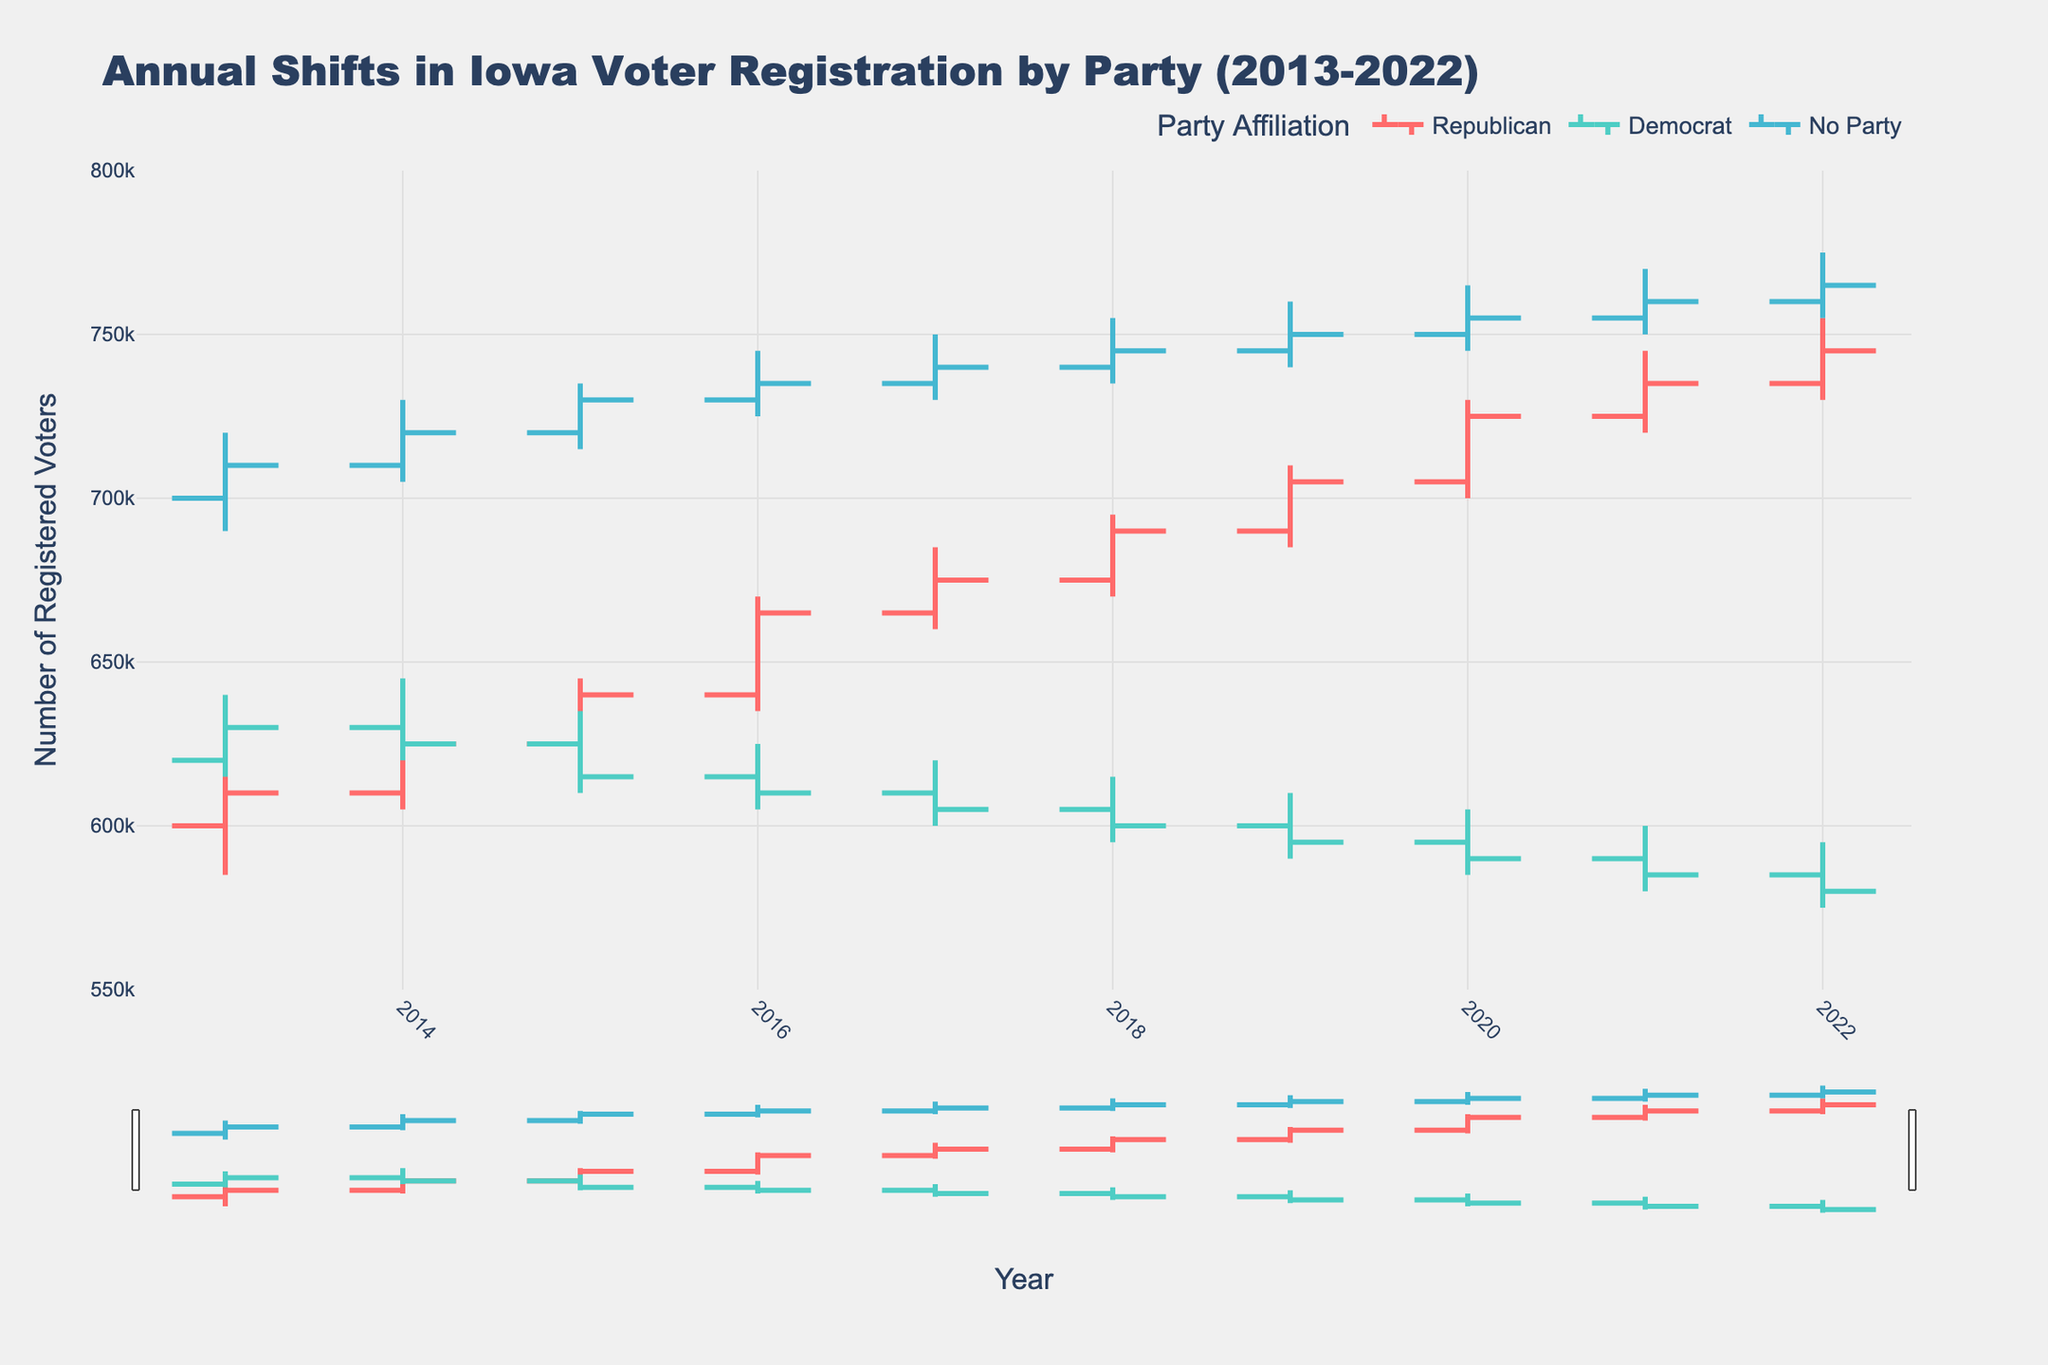What is the title of the figure? The title of the figure is displayed prominently at the top. It reads "Annual Shifts in Iowa Voter Registration by Party (2013-2022)."
Answer: Annual Shifts in Iowa Voter Registration by Party (2013-2022) What are the three political parties represented in the figure? The three political parties are indicated by different colors in the plot legend. They are "Republican," "Democrat," and "No Party."
Answer: Republican, Democrat, No Party Between which years does the data range span? The x-axis of the chart marks the years from the start to end of the data. It runs from 2013 to 2022.
Answer: 2013 to 2022 Which party had the highest number of registered voters at the end of 2022? By examining the close value for each party in 2022, the "No Party" category has the highest number of registered voters with a close of 765,000.
Answer: No Party In which year did the Democrat party have the lowest number of registered voters, and what was the number? The lowest close value for Democrats is seen at the end of the chart. In 2022, it was 580,000.
Answer: 2022, 580,000 Between 2016 and 2017, how did the number of registered voters change for Republicans? To find the change, compare the close value in 2016 (665,000) and 2017 (675,000). The registered voters increased by 10,000.
Answer: Increased by 10,000 How many times did the "No Party" affiliation have a closing value higher than 750,000? Reviewing the closing values each year for the "No Party" affiliation, this happened four times: in 2019, 2020, 2021, and 2022.
Answer: Four times Which party and in which year experienced the highest spike in the number of registered voters during the decade? The "High" value across all years and parties shows the No Party in 2021 with a high of 770,000.
Answer: No Party, 2021 In which year did the Republican party have the smallest annual fluctuation in voter registration numbers, and what are the high and low values for that year? To determine this, compare the high and low values for each year for Republicans. 2017 had the smallest range between its high (685,000) and low (660,000), a fluctuation of 25,000.
Answer: 2017, High: 685,000, Low: 660,000 